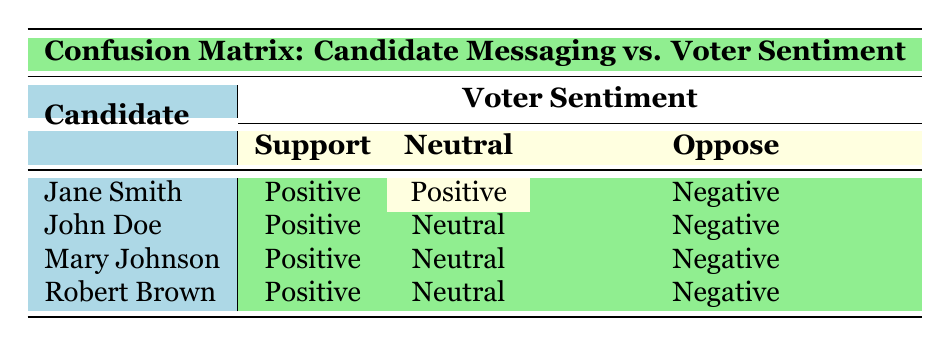What is the voter sentiment for Jane Smith's positive messaging? According to the table, Jane Smith's positive message results in voter sentiment categorized as "support." This is obtained directly from the corresponding cell in the "Support" column under "Jane Smith."
Answer: support How many candidates received "neutral" voter sentiment for their messages? Examining the rows for voter sentiment categorized as "neutral," both John Doe and Mary Johnson have a "neutral" response. Since these two candidates have votes labeled as neutral, the total is 2.
Answer: 2 Did Robert Brown's negative messaging lead to "support" voter sentiment? Upon looking at the table, Robert Brown's negative message correlates with "oppose" voter sentiment, not "support." The information is directly visible in the "Negative" row under Robert Brown.
Answer: no Which candidate received the most "support" sentiment based on positive messaging? Reviewing the table, every candidate showed "support" for their positive messaging, indicating that they all received the same level of "support" sentiment in this context. Therefore, it is not applicable to identify any single candidate as having received more than the others.
Answer: all candidates What is the total count of "oppose" sentiments across all candidates? By analyzing the candidates, we see that each candidate has a single "oppose" sentiment: Jane Smith, John Doe, Mary Johnson, and Robert Brown. Therefore, we add these individual "oppose" cases: 1 for each candidate gives us a total of 4 "oppose" sentiments.
Answer: 4 